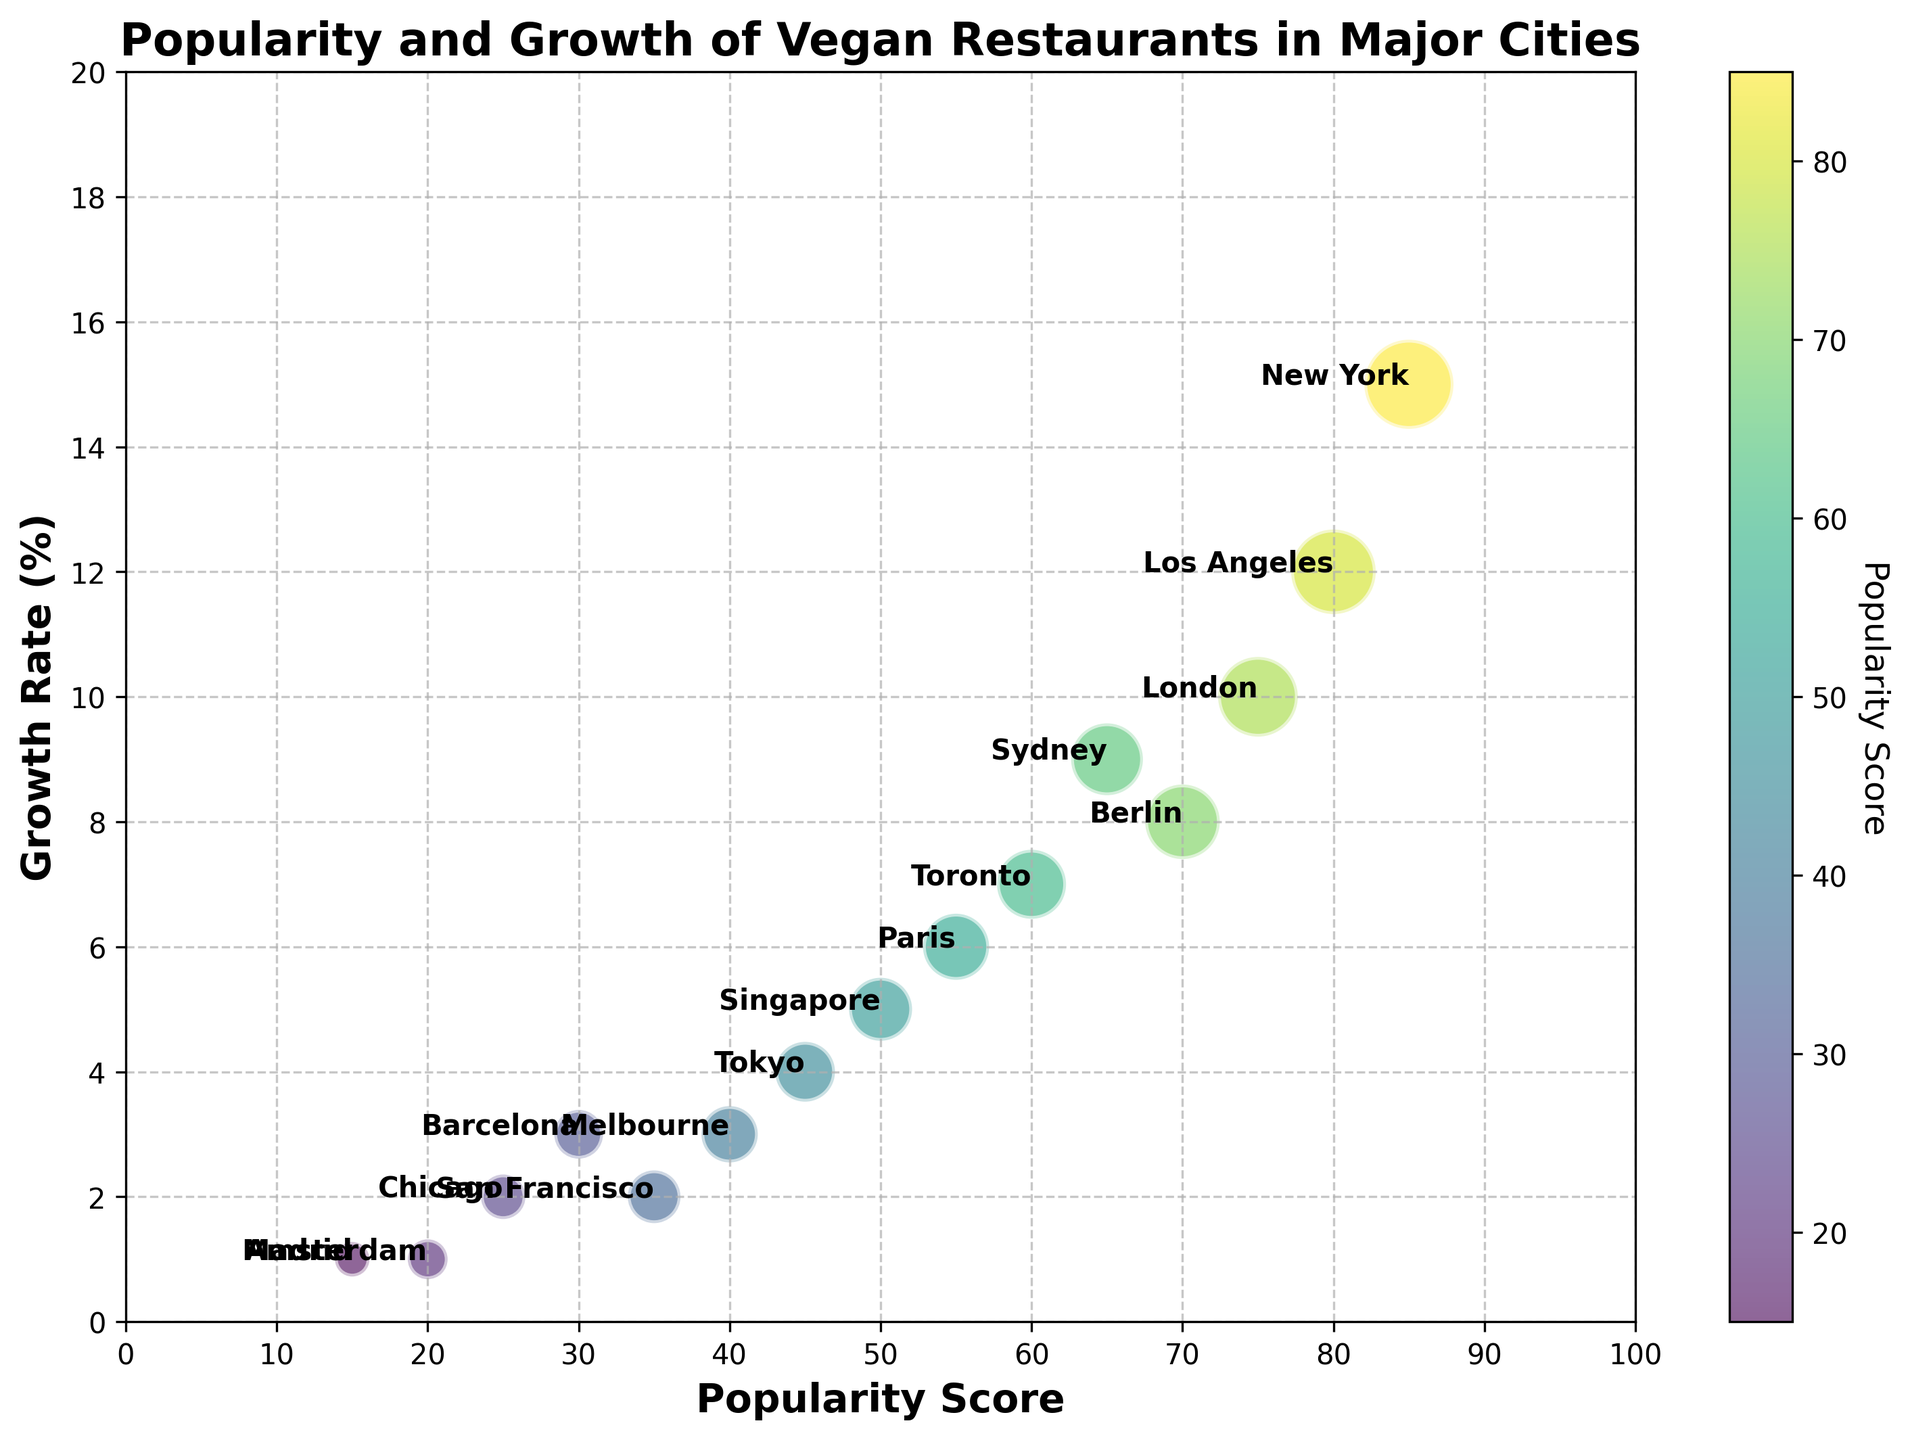Which city has the highest popularity score? By looking at the chart, you can see that the city with the highest positioning on the x-axis, representing popularity score, is New York.
Answer: New York Which city has the lowest growth rate among all? The city with the lowest positioning on the y-axis, representing growth rate, is either Amsterdam or Madrid, both with a growth rate of 1%.
Answer: Amsterdam or Madrid Between Berlin and Sydney, which city has a higher growth rate? By comparing the positions of Berlin and Sydney on the y-axis, we find that Berlin has a growth rate of 8% while Sydney has a growth rate of 9%.
Answer: Sydney What is the sum of the growth rates for Los Angeles and London? Los Angeles has a growth rate of 12% and London has a growth rate of 10%. Adding them together results in 12% + 10% = 22%.
Answer: 22% How does the bubble size (popularity) of New York compare to Tokyo? The bubble representing New York is visually larger than the bubble representing Tokyo, indicating that New York has higher popularity. Specifically, New York has a bubble size of 20 while Tokyo has a bubble size of 9.
Answer: New York has a larger bubble size Which city has the highest combination of popularity score and growth rate? Adding the popularity scores and growth rates for all cities, New York has the highest combined value with a popularity score of 85 and a growth rate of 15, resulting in 85 + 15 = 100.
Answer: New York What is the difference in growth rate between the cities with the highest and lowest popularity scores? New York has the highest popularity score (85) with a growth rate of 15%, and Madrid has the lowest popularity score (15) with a growth rate of 1%. Hence, the difference is 15% - 1% = 14%.
Answer: 14% Which city in the bubble chart has a popularity score equal to its growth rate multiplied by 5? To find this, divide the popularity score by the growth rate for each city. Paris has a popularity score of 55 and a growth rate of 6%. 55/6 ≈ 9.17, which is not an integer. Beijing, with a popularity score of 50 and a growth rate of 5, 50/5 = 10, matches.
Answer: Singapore What are the bubble sizes of the cities with a growth rate of 2%? From the chart, San Francisco and Chicago both have a growth rate of 2%. San Francisco's bubble size is 7 and Chicago's bubble size is 5.
Answer: 7 (San Francisco) and 5 (Chicago) Is there any city that has a lower bubble size but a higher growth rate than Melbourne? Melbourne has a bubble size of 8 and a growth rate of 3%. Chicago has a bubble size of 5 but also a growth rate of 2%, so it doesn't qualify. Barcelona has a bubble size of 6 and a growth rate of 3%, which matches but does not exceed Melbourne’s growth rate. Thus, no.
Answer: No 